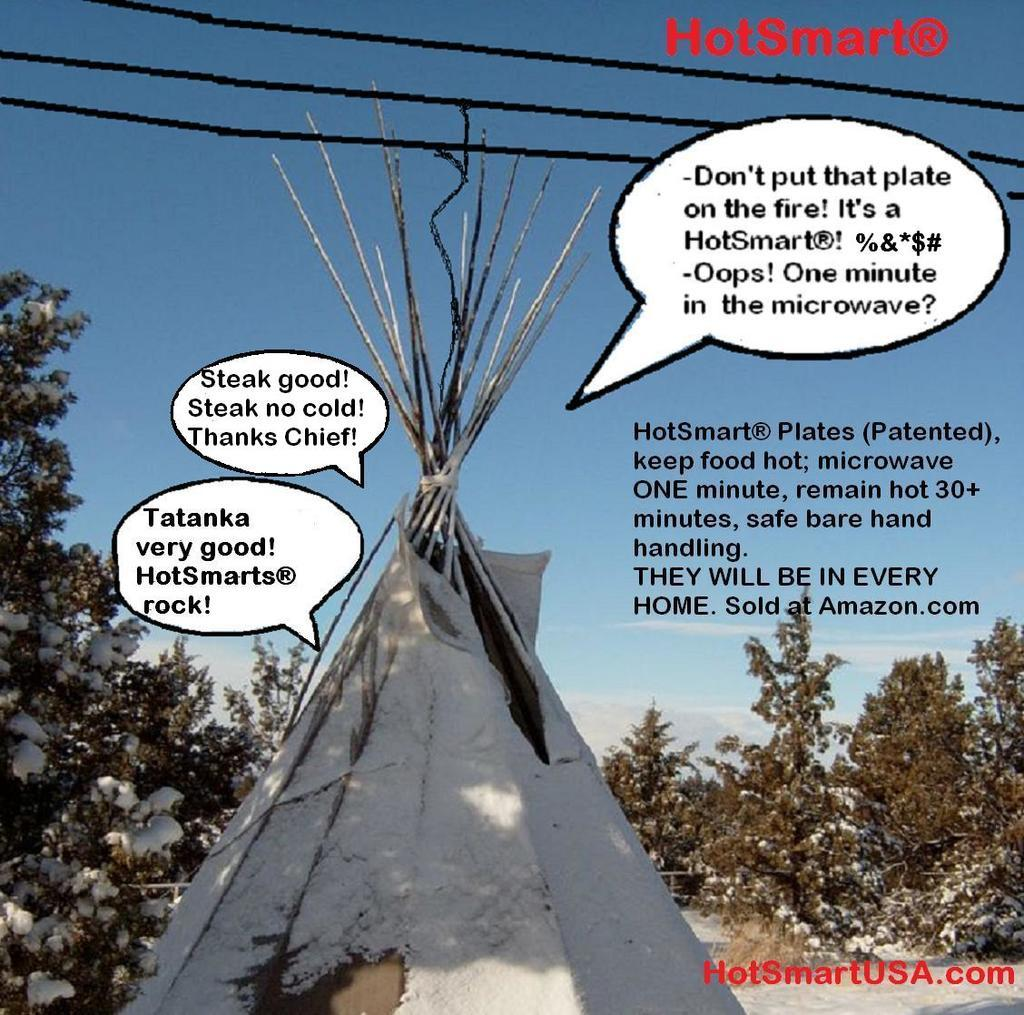What is the predominant weather condition in the image? There is snow in the image, indicating a cold and wintry condition. What type of vegetation can be seen at the bottom of the image? There are trees at the bottom of the image. What is visible at the top of the image? The sky is visible at the top of the image. What is written or depicted in the image? There are texts in the image. Where are the scissors located in the image? There are no scissors present in the image. What type of flame can be seen in the image? There is no flame present in the image. 